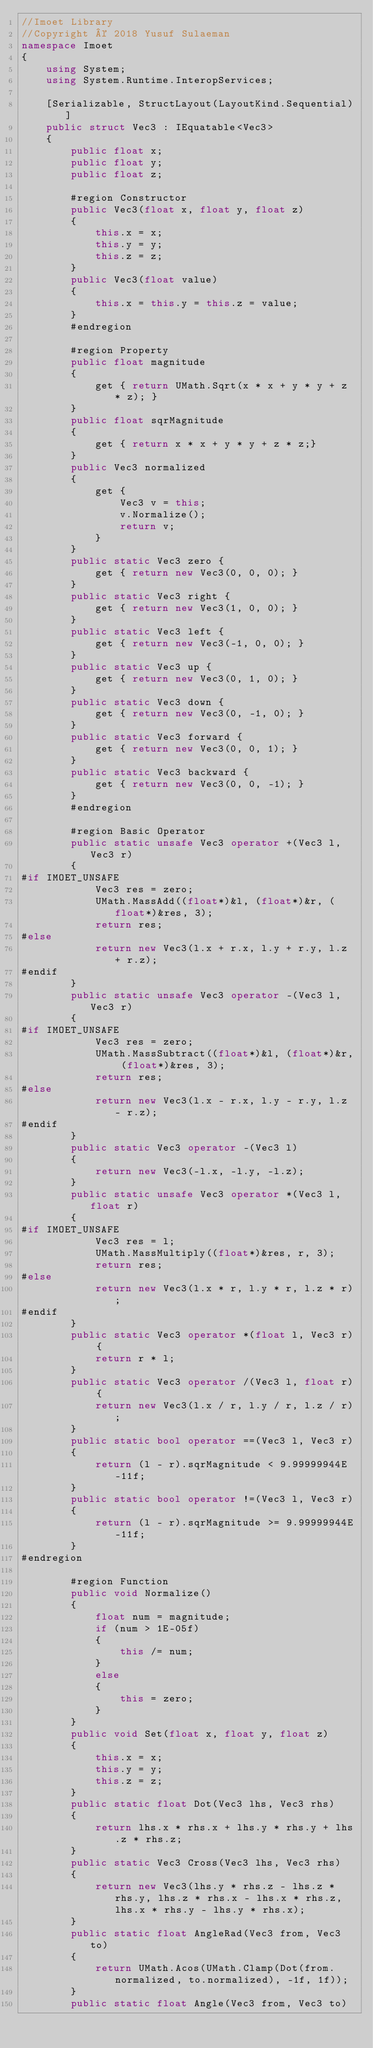Convert code to text. <code><loc_0><loc_0><loc_500><loc_500><_C#_>//Imoet Library
//Copyright © 2018 Yusuf Sulaeman
namespace Imoet
{
    using System;
    using System.Runtime.InteropServices;

    [Serializable, StructLayout(LayoutKind.Sequential)]
    public struct Vec3 : IEquatable<Vec3>
    {
        public float x;
        public float y;
        public float z;

        #region Constructor
        public Vec3(float x, float y, float z)
        {
            this.x = x;
            this.y = y;
            this.z = z;
        }
        public Vec3(float value)
        {
            this.x = this.y = this.z = value;
        }
        #endregion

        #region Property
        public float magnitude
        {
            get { return UMath.Sqrt(x * x + y * y + z * z); }
        }
        public float sqrMagnitude
        {
            get { return x * x + y * y + z * z;}
        }
        public Vec3 normalized
        {
            get {
                Vec3 v = this;
                v.Normalize();
                return v;
            }
        }
        public static Vec3 zero {
            get { return new Vec3(0, 0, 0); }
        }
        public static Vec3 right {
            get { return new Vec3(1, 0, 0); }
        }
        public static Vec3 left {
            get { return new Vec3(-1, 0, 0); }
        }
        public static Vec3 up {
            get { return new Vec3(0, 1, 0); }
        }
        public static Vec3 down {
            get { return new Vec3(0, -1, 0); }
        }
        public static Vec3 forward {
            get { return new Vec3(0, 0, 1); }
        }
        public static Vec3 backward {
            get { return new Vec3(0, 0, -1); }
        }
        #endregion

        #region Basic Operator
        public static unsafe Vec3 operator +(Vec3 l, Vec3 r)
        {
#if IMOET_UNSAFE
            Vec3 res = zero;
            UMath.MassAdd((float*)&l, (float*)&r, (float*)&res, 3);
            return res;
#else
            return new Vec3(l.x + r.x, l.y + r.y, l.z + r.z);
#endif
        }
        public static unsafe Vec3 operator -(Vec3 l, Vec3 r)
        {
#if IMOET_UNSAFE
            Vec3 res = zero;
            UMath.MassSubtract((float*)&l, (float*)&r, (float*)&res, 3);
            return res;
#else
            return new Vec3(l.x - r.x, l.y - r.y, l.z - r.z);
#endif
        }
        public static Vec3 operator -(Vec3 l)
        {
            return new Vec3(-l.x, -l.y, -l.z);
        }
        public static unsafe Vec3 operator *(Vec3 l, float r)
        {
#if IMOET_UNSAFE
            Vec3 res = l;
            UMath.MassMultiply((float*)&res, r, 3);
            return res;
#else
            return new Vec3(l.x * r, l.y * r, l.z * r);
#endif
        }
        public static Vec3 operator *(float l, Vec3 r) {
            return r * l;
        }
        public static Vec3 operator /(Vec3 l, float r) {
            return new Vec3(l.x / r, l.y / r, l.z / r);
        }
        public static bool operator ==(Vec3 l, Vec3 r)
        {
            return (l - r).sqrMagnitude < 9.99999944E-11f;
        }
        public static bool operator !=(Vec3 l, Vec3 r)
        {
            return (l - r).sqrMagnitude >= 9.99999944E-11f;
        }
#endregion

        #region Function
        public void Normalize()
        {
            float num = magnitude;
            if (num > 1E-05f)
            {
                this /= num;
            }
            else
            {
                this = zero;
            }
        }
        public void Set(float x, float y, float z)
        {
            this.x = x;
            this.y = y;
            this.z = z;
        }
        public static float Dot(Vec3 lhs, Vec3 rhs)
        {
            return lhs.x * rhs.x + lhs.y * rhs.y + lhs.z * rhs.z;
        }
        public static Vec3 Cross(Vec3 lhs, Vec3 rhs)
        {
            return new Vec3(lhs.y * rhs.z - lhs.z * rhs.y, lhs.z * rhs.x - lhs.x * rhs.z, lhs.x * rhs.y - lhs.y * rhs.x);
        }
        public static float AngleRad(Vec3 from, Vec3 to)
        {
            return UMath.Acos(UMath.Clamp(Dot(from.normalized, to.normalized), -1f, 1f));
        }
        public static float Angle(Vec3 from, Vec3 to)</code> 